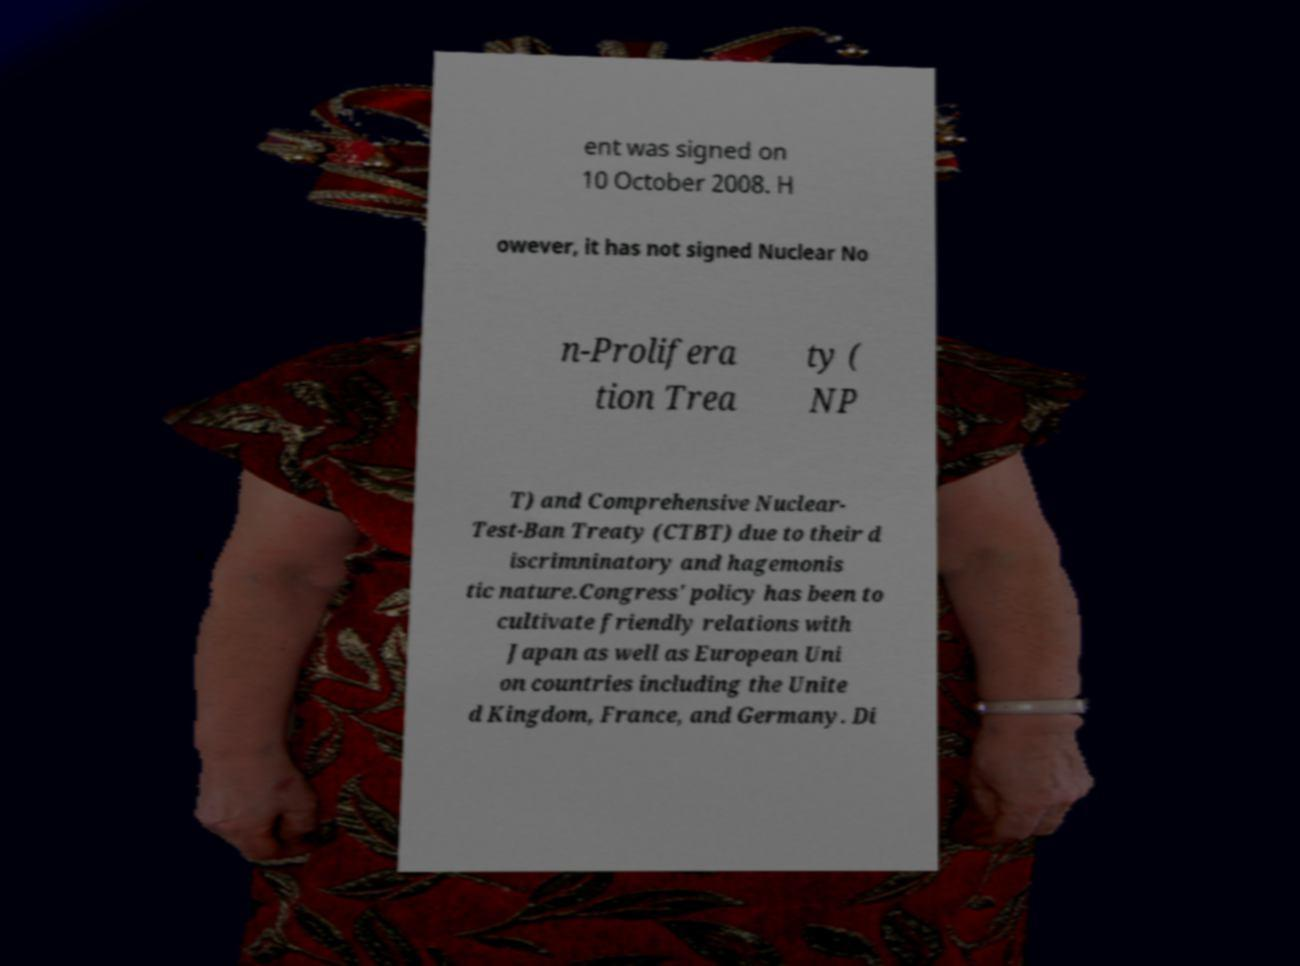Could you assist in decoding the text presented in this image and type it out clearly? ent was signed on 10 October 2008. H owever, it has not signed Nuclear No n-Prolifera tion Trea ty ( NP T) and Comprehensive Nuclear- Test-Ban Treaty (CTBT) due to their d iscrimninatory and hagemonis tic nature.Congress' policy has been to cultivate friendly relations with Japan as well as European Uni on countries including the Unite d Kingdom, France, and Germany. Di 